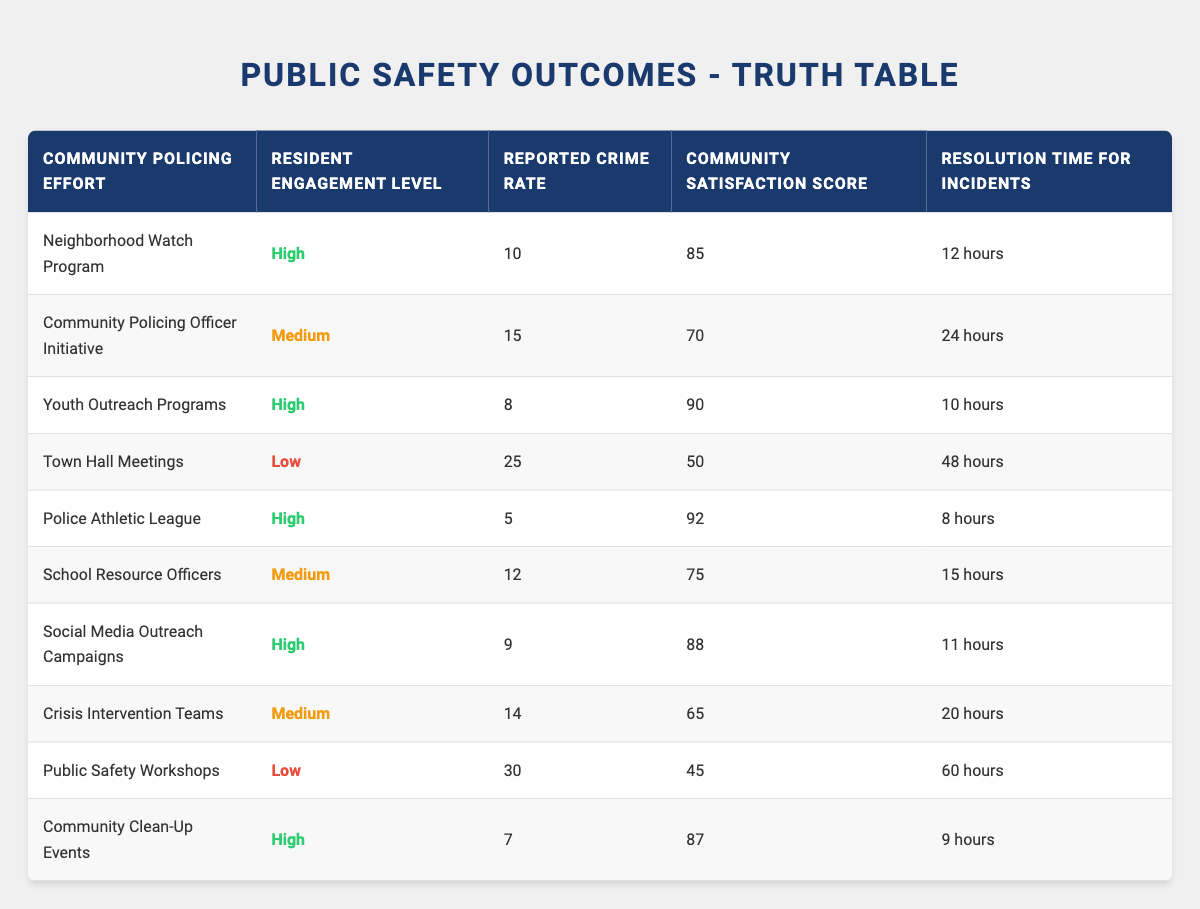What is the reported crime rate for the Police Athletic League? The Police Athletic League has a reported crime rate listed in the table as 5.
Answer: 5 What community policing effort has the highest community satisfaction score? The Police Athletic League has the highest community satisfaction score at 92.
Answer: 92 Is the resident engagement level for Town Hall Meetings high? The resident engagement level for Town Hall Meetings is low, as noted in the table.
Answer: No What is the average resolution time for incidents across all community policing efforts with high resident engagement? The high resident engagement efforts are Neighborhood Watch Program, Youth Outreach Programs, Police Athletic League, Social Media Outreach Campaigns, and Community Clean-Up Events. Their resolution times are 12 hours, 10 hours, 8 hours, 11 hours, and 9 hours, respectively. The average is (12 + 10 + 8 + 11 + 9) / 5 = 10.
Answer: 10 hours Which community policing effort has both high resident engagement and the lowest reported crime rate? The Police Athletic League has high resident engagement and a reported crime rate of 5, which is the lowest among all entries in the table.
Answer: Police Athletic League How many community policing efforts have a medium level of resident engagement? There are three efforts with a medium level of resident engagement: Community Policing Officer Initiative, School Resource Officers, and Crisis Intervention Teams.
Answer: 3 What is the difference in reported crime rate between the highest and lowest community policing efforts listed? The highest reported crime rate is 30 for Public Safety Workshops, and the lowest is 5 for the Police Athletic League. The difference is 30 - 5 = 25.
Answer: 25 Is there a correlation between high resident engagement and a low reported crime rate in the table? Yes, all high resident engagement efforts have reported crime rates below 15, suggesting a possible correlation.
Answer: Yes What is the median community satisfaction score for the community policing efforts with low resident engagement? The low resident engagement efforts are Town Hall Meetings and Public Safety Workshops with satisfaction scores of 50 and 45, respectively. The median score is (50 + 45) / 2 = 47.5.
Answer: 47.5 